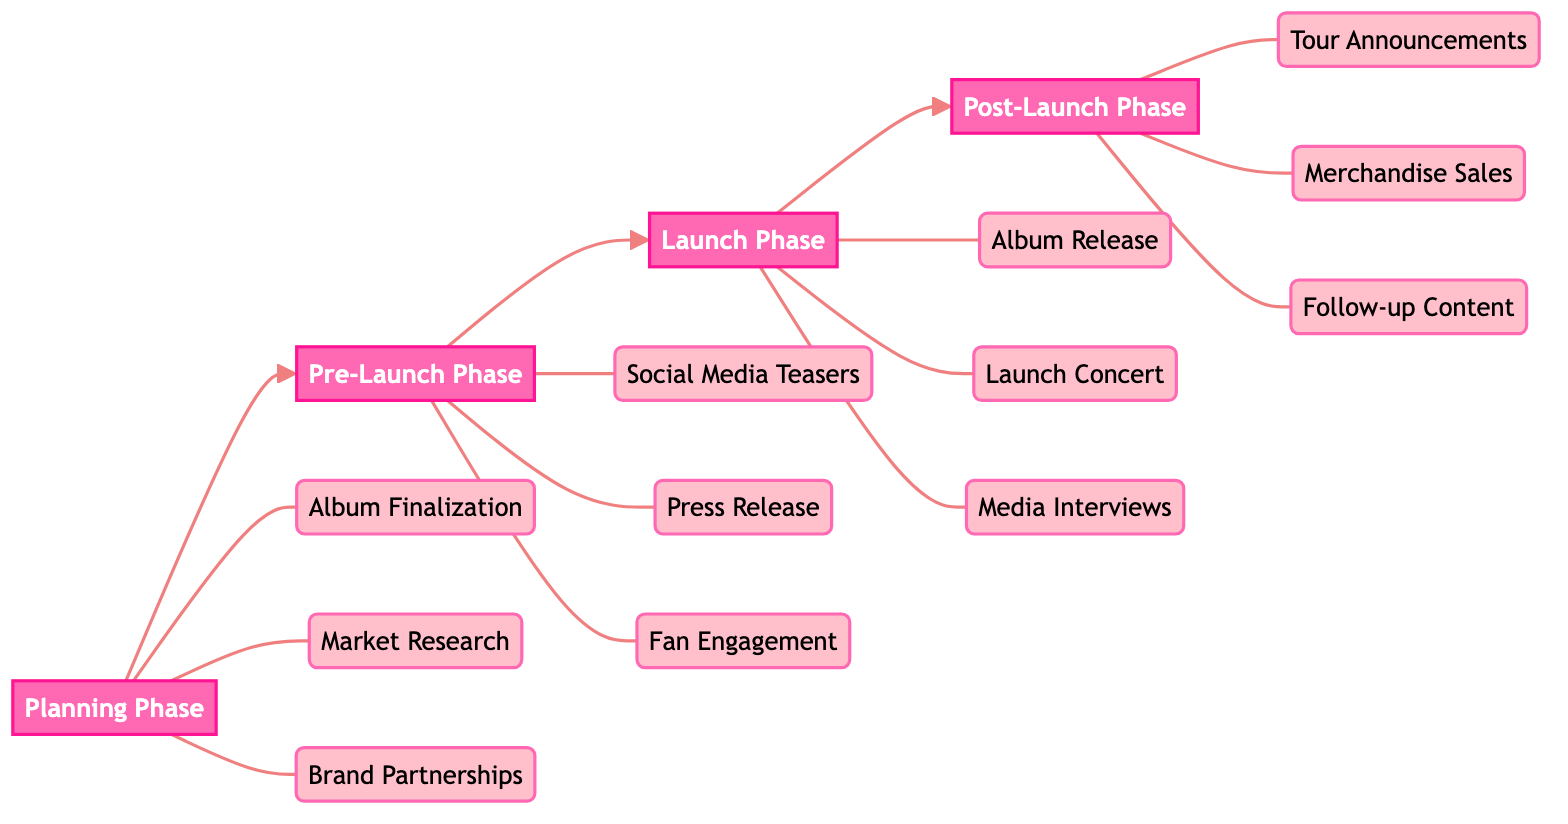What is the first phase in the diagram? The diagram lists the phases sequentially, starting with "Planning Phase". This is the initial milestone before moving to the next phases.
Answer: Planning Phase How many milestones are in the Launch Phase? The Launch Phase includes three specific milestones: "Album Release," "Launch Concert," and "Media Interviews." This can be counted directly from the diagram.
Answer: 3 What comes after the Pre-Launch Phase? The diagram illustrates a flow from the Pre-Launch Phase to the next, which is the Launch Phase. This indicates the chronological order of the phases.
Answer: Launch Phase Which brand partnership is mentioned in the Planning Phase? In the Planning Phase under brand partnerships, "Samsung" is specifically listed as one of the potential collaborators. This can be referenced directly in the diagram's milestones.
Answer: Samsung What is the last milestone in the Promotional Tour Pathway? According to the diagram, the final milestone listed is "Follow-up Content," which appears in the Post-Launch Phase. This is the last activity in the pathway.
Answer: Follow-up Content Which platforms are utilized for social media teasers? The diagram specifies that social media teasers are to be conducted on "Instagram, Weibo, TikTok." These platforms are clearly mentioned in the Pre-Launch Phase.
Answer: Instagram, Weibo, TikTok How is the Launch Concert presented in the diagram? The Launch Concert is highlighted as a major milestone within the Launch Phase and is described as "Live streamed on platforms like Bilibili, YouTube.” This indicates its significance in the overall launch strategy.
Answer: Live streamed on platforms like Bilibili, YouTube What is the primary focus of the Market Research milestone? The Market Research milestone is focused on "Use analytics from platforms like Spotify, Apple Music." This describes the goal of this milestone within the Planning Phase.
Answer: Use analytics from platforms like Spotify, Apple Music How many total phases are depicted in the diagram? The diagram details a total of four phases: Planning Phase, Pre-Launch Phase, Launch Phase, and Post-Launch Phase. This can be counted directly from the phase nodes.
Answer: 4 